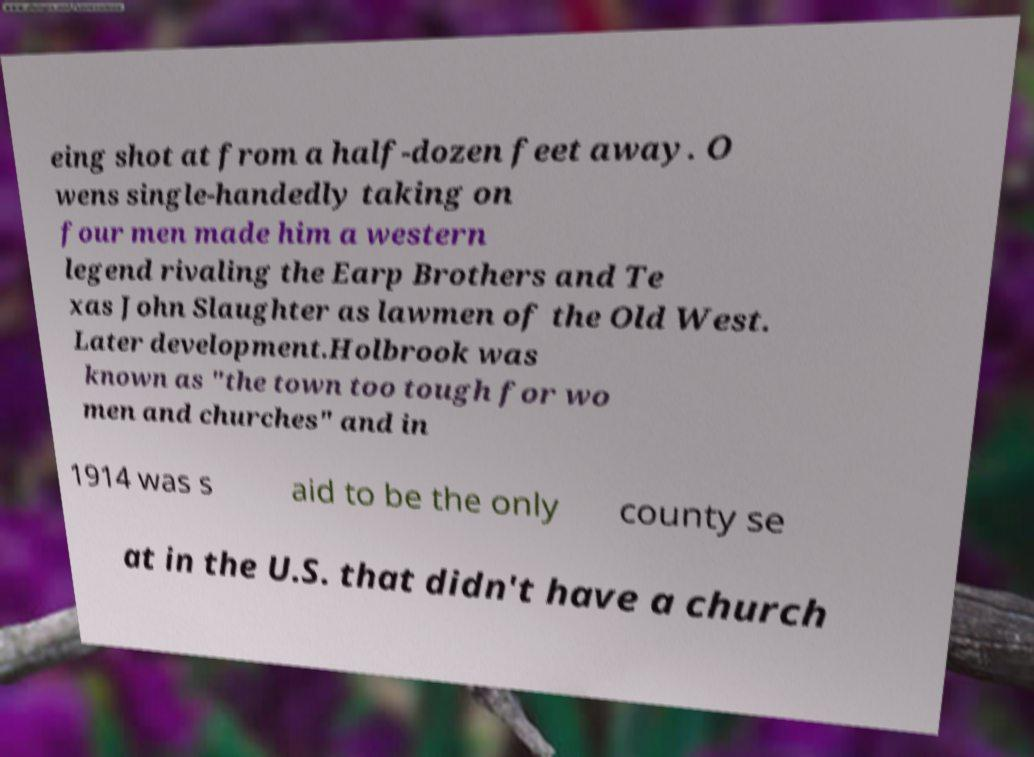Can you read and provide the text displayed in the image?This photo seems to have some interesting text. Can you extract and type it out for me? eing shot at from a half-dozen feet away. O wens single-handedly taking on four men made him a western legend rivaling the Earp Brothers and Te xas John Slaughter as lawmen of the Old West. Later development.Holbrook was known as "the town too tough for wo men and churches" and in 1914 was s aid to be the only county se at in the U.S. that didn't have a church 